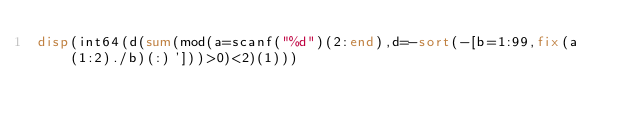<code> <loc_0><loc_0><loc_500><loc_500><_Octave_>disp(int64(d(sum(mod(a=scanf("%d")(2:end),d=-sort(-[b=1:99,fix(a(1:2)./b)(:)']))>0)<2)(1)))</code> 